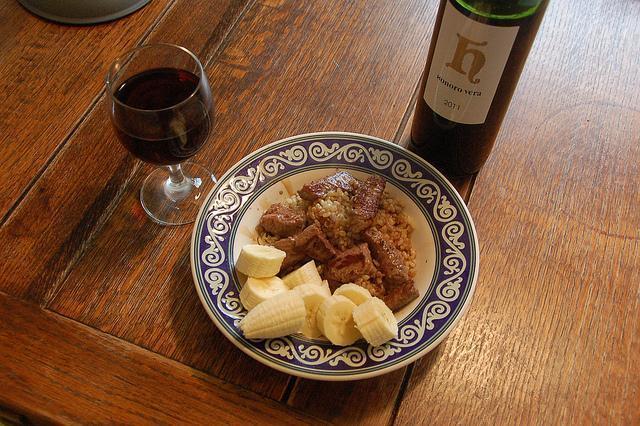Is "The bowl is touching the banana." an appropriate description for the image?
Answer yes or no. Yes. 